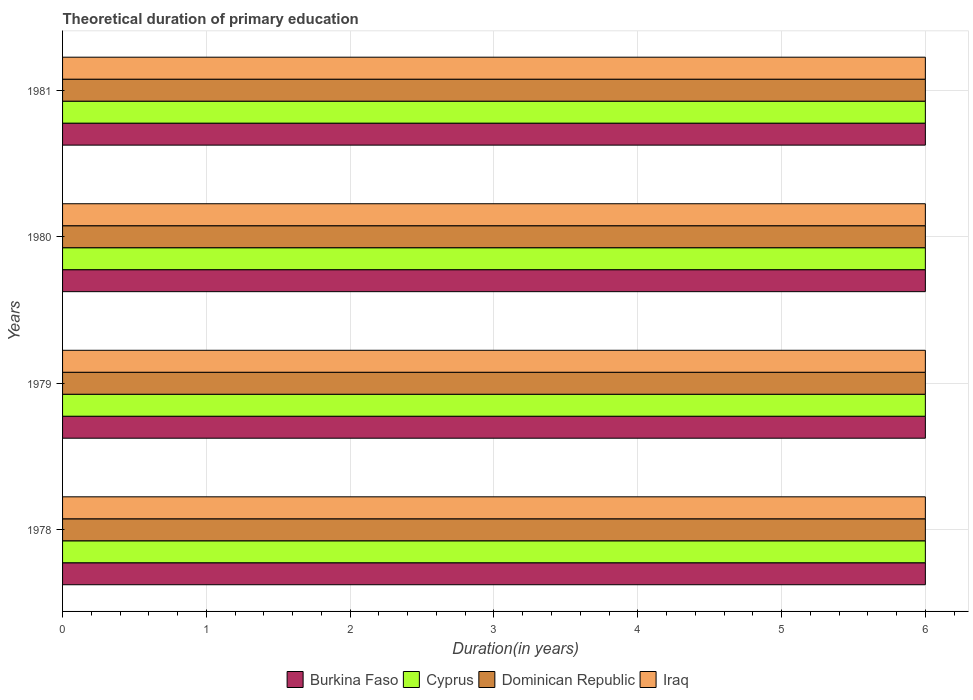Are the number of bars per tick equal to the number of legend labels?
Offer a very short reply. Yes. Are the number of bars on each tick of the Y-axis equal?
Give a very brief answer. Yes. How many bars are there on the 4th tick from the top?
Offer a very short reply. 4. How many bars are there on the 4th tick from the bottom?
Your answer should be very brief. 4. What is the label of the 4th group of bars from the top?
Your answer should be very brief. 1978. What is the total theoretical duration of primary education in Cyprus in 1980?
Make the answer very short. 6. Across all years, what is the minimum total theoretical duration of primary education in Dominican Republic?
Ensure brevity in your answer.  6. In which year was the total theoretical duration of primary education in Iraq maximum?
Provide a short and direct response. 1978. In which year was the total theoretical duration of primary education in Cyprus minimum?
Provide a short and direct response. 1978. What is the total total theoretical duration of primary education in Burkina Faso in the graph?
Provide a succinct answer. 24. What is the difference between the total theoretical duration of primary education in Iraq in 1978 and that in 1981?
Keep it short and to the point. 0. What is the difference between the total theoretical duration of primary education in Dominican Republic in 1981 and the total theoretical duration of primary education in Iraq in 1978?
Your answer should be compact. 0. What is the ratio of the total theoretical duration of primary education in Cyprus in 1979 to that in 1980?
Ensure brevity in your answer.  1. Is the total theoretical duration of primary education in Burkina Faso in 1980 less than that in 1981?
Offer a very short reply. No. What is the difference between the highest and the second highest total theoretical duration of primary education in Cyprus?
Give a very brief answer. 0. What is the difference between the highest and the lowest total theoretical duration of primary education in Iraq?
Provide a short and direct response. 0. Is the sum of the total theoretical duration of primary education in Cyprus in 1978 and 1979 greater than the maximum total theoretical duration of primary education in Iraq across all years?
Offer a terse response. Yes. Is it the case that in every year, the sum of the total theoretical duration of primary education in Burkina Faso and total theoretical duration of primary education in Cyprus is greater than the sum of total theoretical duration of primary education in Iraq and total theoretical duration of primary education in Dominican Republic?
Your response must be concise. No. What does the 1st bar from the top in 1979 represents?
Keep it short and to the point. Iraq. What does the 1st bar from the bottom in 1980 represents?
Provide a short and direct response. Burkina Faso. Is it the case that in every year, the sum of the total theoretical duration of primary education in Cyprus and total theoretical duration of primary education in Dominican Republic is greater than the total theoretical duration of primary education in Iraq?
Ensure brevity in your answer.  Yes. How many bars are there?
Make the answer very short. 16. Are all the bars in the graph horizontal?
Ensure brevity in your answer.  Yes. How many years are there in the graph?
Ensure brevity in your answer.  4. Are the values on the major ticks of X-axis written in scientific E-notation?
Your response must be concise. No. Does the graph contain grids?
Provide a succinct answer. Yes. Where does the legend appear in the graph?
Keep it short and to the point. Bottom center. How are the legend labels stacked?
Your response must be concise. Horizontal. What is the title of the graph?
Your response must be concise. Theoretical duration of primary education. What is the label or title of the X-axis?
Provide a short and direct response. Duration(in years). What is the label or title of the Y-axis?
Offer a very short reply. Years. What is the Duration(in years) of Burkina Faso in 1978?
Your answer should be very brief. 6. What is the Duration(in years) of Dominican Republic in 1978?
Provide a short and direct response. 6. What is the Duration(in years) in Iraq in 1978?
Your answer should be very brief. 6. What is the Duration(in years) in Iraq in 1979?
Keep it short and to the point. 6. What is the Duration(in years) in Cyprus in 1980?
Provide a short and direct response. 6. What is the Duration(in years) in Burkina Faso in 1981?
Your answer should be compact. 6. What is the Duration(in years) of Dominican Republic in 1981?
Keep it short and to the point. 6. What is the Duration(in years) of Iraq in 1981?
Give a very brief answer. 6. Across all years, what is the maximum Duration(in years) in Burkina Faso?
Offer a terse response. 6. Across all years, what is the maximum Duration(in years) of Cyprus?
Your response must be concise. 6. Across all years, what is the maximum Duration(in years) of Iraq?
Give a very brief answer. 6. Across all years, what is the minimum Duration(in years) of Cyprus?
Offer a very short reply. 6. What is the total Duration(in years) in Burkina Faso in the graph?
Give a very brief answer. 24. What is the total Duration(in years) in Dominican Republic in the graph?
Ensure brevity in your answer.  24. What is the difference between the Duration(in years) of Dominican Republic in 1978 and that in 1979?
Make the answer very short. 0. What is the difference between the Duration(in years) of Burkina Faso in 1978 and that in 1980?
Your answer should be compact. 0. What is the difference between the Duration(in years) in Burkina Faso in 1978 and that in 1981?
Offer a very short reply. 0. What is the difference between the Duration(in years) of Dominican Republic in 1978 and that in 1981?
Provide a short and direct response. 0. What is the difference between the Duration(in years) of Iraq in 1978 and that in 1981?
Make the answer very short. 0. What is the difference between the Duration(in years) in Burkina Faso in 1979 and that in 1980?
Give a very brief answer. 0. What is the difference between the Duration(in years) of Cyprus in 1979 and that in 1980?
Provide a succinct answer. 0. What is the difference between the Duration(in years) in Dominican Republic in 1979 and that in 1980?
Your response must be concise. 0. What is the difference between the Duration(in years) of Iraq in 1979 and that in 1980?
Provide a short and direct response. 0. What is the difference between the Duration(in years) in Cyprus in 1979 and that in 1981?
Your answer should be very brief. 0. What is the difference between the Duration(in years) in Dominican Republic in 1979 and that in 1981?
Make the answer very short. 0. What is the difference between the Duration(in years) in Burkina Faso in 1978 and the Duration(in years) in Cyprus in 1979?
Your response must be concise. 0. What is the difference between the Duration(in years) of Burkina Faso in 1978 and the Duration(in years) of Dominican Republic in 1979?
Provide a succinct answer. 0. What is the difference between the Duration(in years) in Burkina Faso in 1978 and the Duration(in years) in Iraq in 1979?
Provide a short and direct response. 0. What is the difference between the Duration(in years) of Cyprus in 1978 and the Duration(in years) of Dominican Republic in 1979?
Offer a terse response. 0. What is the difference between the Duration(in years) in Cyprus in 1978 and the Duration(in years) in Iraq in 1979?
Keep it short and to the point. 0. What is the difference between the Duration(in years) in Burkina Faso in 1978 and the Duration(in years) in Dominican Republic in 1980?
Keep it short and to the point. 0. What is the difference between the Duration(in years) of Burkina Faso in 1978 and the Duration(in years) of Iraq in 1980?
Your answer should be very brief. 0. What is the difference between the Duration(in years) of Cyprus in 1978 and the Duration(in years) of Dominican Republic in 1980?
Ensure brevity in your answer.  0. What is the difference between the Duration(in years) in Cyprus in 1978 and the Duration(in years) in Iraq in 1980?
Keep it short and to the point. 0. What is the difference between the Duration(in years) of Dominican Republic in 1978 and the Duration(in years) of Iraq in 1980?
Your answer should be very brief. 0. What is the difference between the Duration(in years) in Burkina Faso in 1978 and the Duration(in years) in Iraq in 1981?
Ensure brevity in your answer.  0. What is the difference between the Duration(in years) of Cyprus in 1978 and the Duration(in years) of Dominican Republic in 1981?
Your answer should be very brief. 0. What is the difference between the Duration(in years) in Cyprus in 1978 and the Duration(in years) in Iraq in 1981?
Ensure brevity in your answer.  0. What is the difference between the Duration(in years) in Burkina Faso in 1979 and the Duration(in years) in Iraq in 1980?
Your response must be concise. 0. What is the difference between the Duration(in years) in Cyprus in 1979 and the Duration(in years) in Iraq in 1980?
Offer a terse response. 0. What is the difference between the Duration(in years) of Dominican Republic in 1979 and the Duration(in years) of Iraq in 1980?
Make the answer very short. 0. What is the difference between the Duration(in years) in Burkina Faso in 1979 and the Duration(in years) in Cyprus in 1981?
Offer a very short reply. 0. What is the difference between the Duration(in years) of Burkina Faso in 1979 and the Duration(in years) of Dominican Republic in 1981?
Your answer should be very brief. 0. What is the difference between the Duration(in years) of Burkina Faso in 1979 and the Duration(in years) of Iraq in 1981?
Make the answer very short. 0. What is the difference between the Duration(in years) of Cyprus in 1979 and the Duration(in years) of Dominican Republic in 1981?
Provide a short and direct response. 0. What is the difference between the Duration(in years) of Burkina Faso in 1980 and the Duration(in years) of Iraq in 1981?
Offer a terse response. 0. What is the difference between the Duration(in years) of Cyprus in 1980 and the Duration(in years) of Dominican Republic in 1981?
Your answer should be compact. 0. What is the difference between the Duration(in years) in Dominican Republic in 1980 and the Duration(in years) in Iraq in 1981?
Ensure brevity in your answer.  0. What is the average Duration(in years) of Burkina Faso per year?
Ensure brevity in your answer.  6. What is the average Duration(in years) in Cyprus per year?
Offer a very short reply. 6. What is the average Duration(in years) in Iraq per year?
Provide a short and direct response. 6. In the year 1978, what is the difference between the Duration(in years) in Burkina Faso and Duration(in years) in Cyprus?
Ensure brevity in your answer.  0. In the year 1978, what is the difference between the Duration(in years) of Burkina Faso and Duration(in years) of Dominican Republic?
Provide a succinct answer. 0. In the year 1978, what is the difference between the Duration(in years) of Burkina Faso and Duration(in years) of Iraq?
Keep it short and to the point. 0. In the year 1978, what is the difference between the Duration(in years) in Cyprus and Duration(in years) in Dominican Republic?
Ensure brevity in your answer.  0. In the year 1978, what is the difference between the Duration(in years) in Cyprus and Duration(in years) in Iraq?
Give a very brief answer. 0. In the year 1979, what is the difference between the Duration(in years) in Burkina Faso and Duration(in years) in Cyprus?
Ensure brevity in your answer.  0. In the year 1979, what is the difference between the Duration(in years) in Burkina Faso and Duration(in years) in Iraq?
Provide a succinct answer. 0. In the year 1979, what is the difference between the Duration(in years) of Cyprus and Duration(in years) of Dominican Republic?
Offer a terse response. 0. In the year 1979, what is the difference between the Duration(in years) in Cyprus and Duration(in years) in Iraq?
Offer a very short reply. 0. In the year 1979, what is the difference between the Duration(in years) of Dominican Republic and Duration(in years) of Iraq?
Offer a very short reply. 0. In the year 1980, what is the difference between the Duration(in years) of Burkina Faso and Duration(in years) of Cyprus?
Make the answer very short. 0. In the year 1980, what is the difference between the Duration(in years) of Burkina Faso and Duration(in years) of Dominican Republic?
Keep it short and to the point. 0. In the year 1980, what is the difference between the Duration(in years) of Burkina Faso and Duration(in years) of Iraq?
Make the answer very short. 0. In the year 1980, what is the difference between the Duration(in years) of Cyprus and Duration(in years) of Iraq?
Offer a terse response. 0. In the year 1980, what is the difference between the Duration(in years) of Dominican Republic and Duration(in years) of Iraq?
Offer a very short reply. 0. In the year 1981, what is the difference between the Duration(in years) of Burkina Faso and Duration(in years) of Dominican Republic?
Make the answer very short. 0. In the year 1981, what is the difference between the Duration(in years) of Cyprus and Duration(in years) of Dominican Republic?
Ensure brevity in your answer.  0. In the year 1981, what is the difference between the Duration(in years) in Cyprus and Duration(in years) in Iraq?
Ensure brevity in your answer.  0. What is the ratio of the Duration(in years) in Cyprus in 1978 to that in 1979?
Make the answer very short. 1. What is the ratio of the Duration(in years) in Dominican Republic in 1978 to that in 1979?
Offer a very short reply. 1. What is the ratio of the Duration(in years) in Iraq in 1978 to that in 1979?
Provide a succinct answer. 1. What is the ratio of the Duration(in years) in Cyprus in 1978 to that in 1980?
Offer a terse response. 1. What is the ratio of the Duration(in years) of Dominican Republic in 1978 to that in 1980?
Ensure brevity in your answer.  1. What is the ratio of the Duration(in years) in Iraq in 1978 to that in 1980?
Offer a very short reply. 1. What is the ratio of the Duration(in years) in Burkina Faso in 1978 to that in 1981?
Your answer should be compact. 1. What is the ratio of the Duration(in years) of Cyprus in 1978 to that in 1981?
Provide a succinct answer. 1. What is the ratio of the Duration(in years) of Burkina Faso in 1979 to that in 1980?
Provide a short and direct response. 1. What is the ratio of the Duration(in years) of Cyprus in 1979 to that in 1980?
Offer a terse response. 1. What is the ratio of the Duration(in years) of Iraq in 1979 to that in 1980?
Your response must be concise. 1. What is the ratio of the Duration(in years) in Burkina Faso in 1979 to that in 1981?
Make the answer very short. 1. What is the ratio of the Duration(in years) in Iraq in 1979 to that in 1981?
Your response must be concise. 1. What is the ratio of the Duration(in years) of Burkina Faso in 1980 to that in 1981?
Keep it short and to the point. 1. What is the ratio of the Duration(in years) of Dominican Republic in 1980 to that in 1981?
Make the answer very short. 1. What is the ratio of the Duration(in years) of Iraq in 1980 to that in 1981?
Your response must be concise. 1. What is the difference between the highest and the second highest Duration(in years) in Cyprus?
Provide a short and direct response. 0. What is the difference between the highest and the second highest Duration(in years) in Iraq?
Make the answer very short. 0. What is the difference between the highest and the lowest Duration(in years) of Burkina Faso?
Provide a short and direct response. 0. What is the difference between the highest and the lowest Duration(in years) of Dominican Republic?
Offer a terse response. 0. What is the difference between the highest and the lowest Duration(in years) in Iraq?
Your response must be concise. 0. 